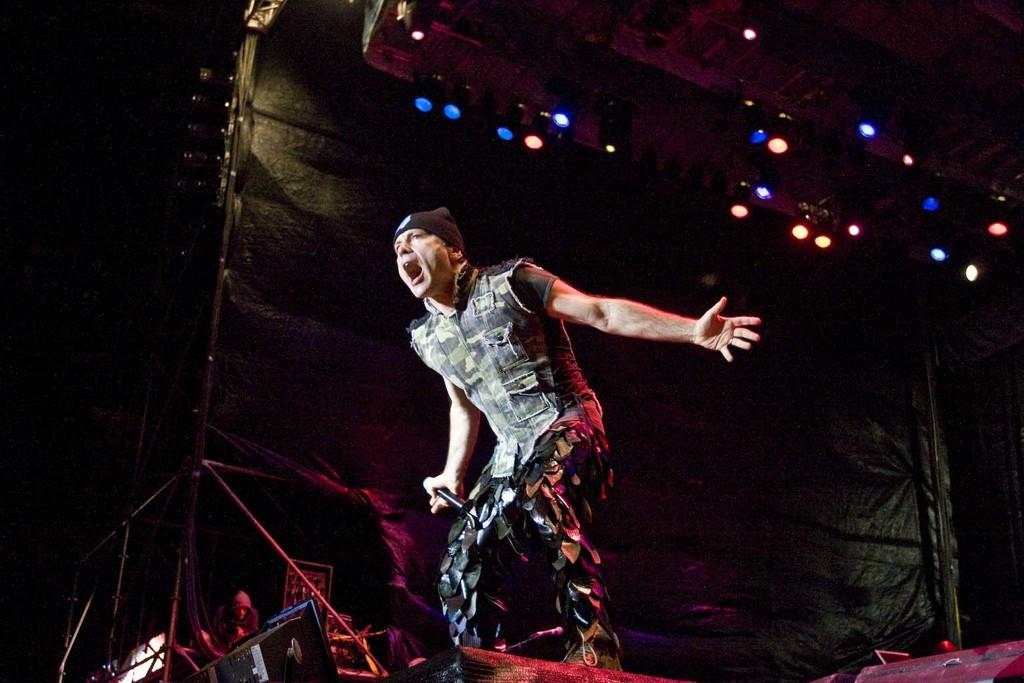What is the man in the image doing? The man is standing in the image and holding a microphone. Can you describe the background of the image? The background of the image is dark, and there is a person visible in the background along with rods and electrical devices. What is the purpose of the microphone the man is holding? The microphone suggests that the man might be speaking or performing in front of an audience or at an event. What can be seen at the top of the image? Lights are visible at the top of the image, lights are visible. What type of bait is the man using to catch fish in the image? There is no indication of fishing or bait in the image; the man is holding a microphone and standing in front of a dark background with lights and electrical devices. 